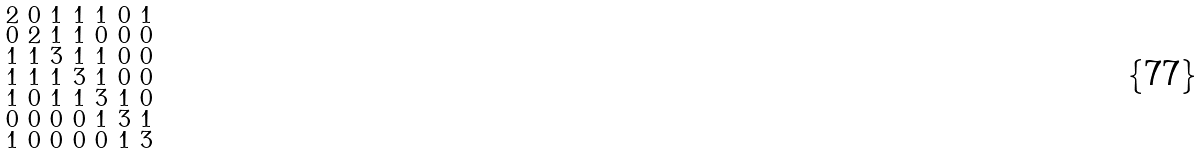Convert formula to latex. <formula><loc_0><loc_0><loc_500><loc_500>\begin{smallmatrix} 2 & 0 & 1 & 1 & 1 & 0 & 1 \\ 0 & 2 & 1 & 1 & 0 & 0 & 0 \\ 1 & 1 & 3 & 1 & 1 & 0 & 0 \\ 1 & 1 & 1 & 3 & 1 & 0 & 0 \\ 1 & 0 & 1 & 1 & 3 & 1 & 0 \\ 0 & 0 & 0 & 0 & 1 & 3 & 1 \\ 1 & 0 & 0 & 0 & 0 & 1 & 3 \end{smallmatrix}</formula> 